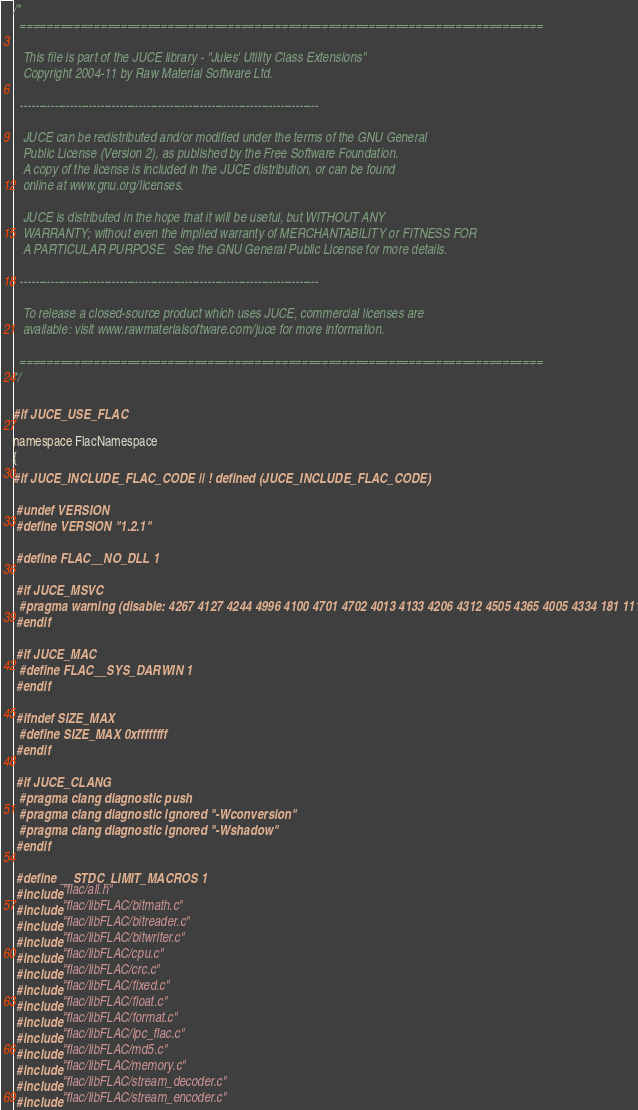Convert code to text. <code><loc_0><loc_0><loc_500><loc_500><_C++_>/*
  ==============================================================================

   This file is part of the JUCE library - "Jules' Utility Class Extensions"
   Copyright 2004-11 by Raw Material Software Ltd.

  ------------------------------------------------------------------------------

   JUCE can be redistributed and/or modified under the terms of the GNU General
   Public License (Version 2), as published by the Free Software Foundation.
   A copy of the license is included in the JUCE distribution, or can be found
   online at www.gnu.org/licenses.

   JUCE is distributed in the hope that it will be useful, but WITHOUT ANY
   WARRANTY; without even the implied warranty of MERCHANTABILITY or FITNESS FOR
   A PARTICULAR PURPOSE.  See the GNU General Public License for more details.

  ------------------------------------------------------------------------------

   To release a closed-source product which uses JUCE, commercial licenses are
   available: visit www.rawmaterialsoftware.com/juce for more information.

  ==============================================================================
*/

#if JUCE_USE_FLAC

namespace FlacNamespace
{
#if JUCE_INCLUDE_FLAC_CODE || ! defined (JUCE_INCLUDE_FLAC_CODE)

 #undef VERSION
 #define VERSION "1.2.1"

 #define FLAC__NO_DLL 1

 #if JUCE_MSVC
  #pragma warning (disable: 4267 4127 4244 4996 4100 4701 4702 4013 4133 4206 4312 4505 4365 4005 4334 181 111)
 #endif

 #if JUCE_MAC
  #define FLAC__SYS_DARWIN 1
 #endif

 #ifndef SIZE_MAX
  #define SIZE_MAX 0xffffffff
 #endif

 #if JUCE_CLANG
  #pragma clang diagnostic push
  #pragma clang diagnostic ignored "-Wconversion"
  #pragma clang diagnostic ignored "-Wshadow"
 #endif

 #define __STDC_LIMIT_MACROS 1
 #include "flac/all.h"
 #include "flac/libFLAC/bitmath.c"
 #include "flac/libFLAC/bitreader.c"
 #include "flac/libFLAC/bitwriter.c"
 #include "flac/libFLAC/cpu.c"
 #include "flac/libFLAC/crc.c"
 #include "flac/libFLAC/fixed.c"
 #include "flac/libFLAC/float.c"
 #include "flac/libFLAC/format.c"
 #include "flac/libFLAC/lpc_flac.c"
 #include "flac/libFLAC/md5.c"
 #include "flac/libFLAC/memory.c"
 #include "flac/libFLAC/stream_decoder.c"
 #include "flac/libFLAC/stream_encoder.c"</code> 